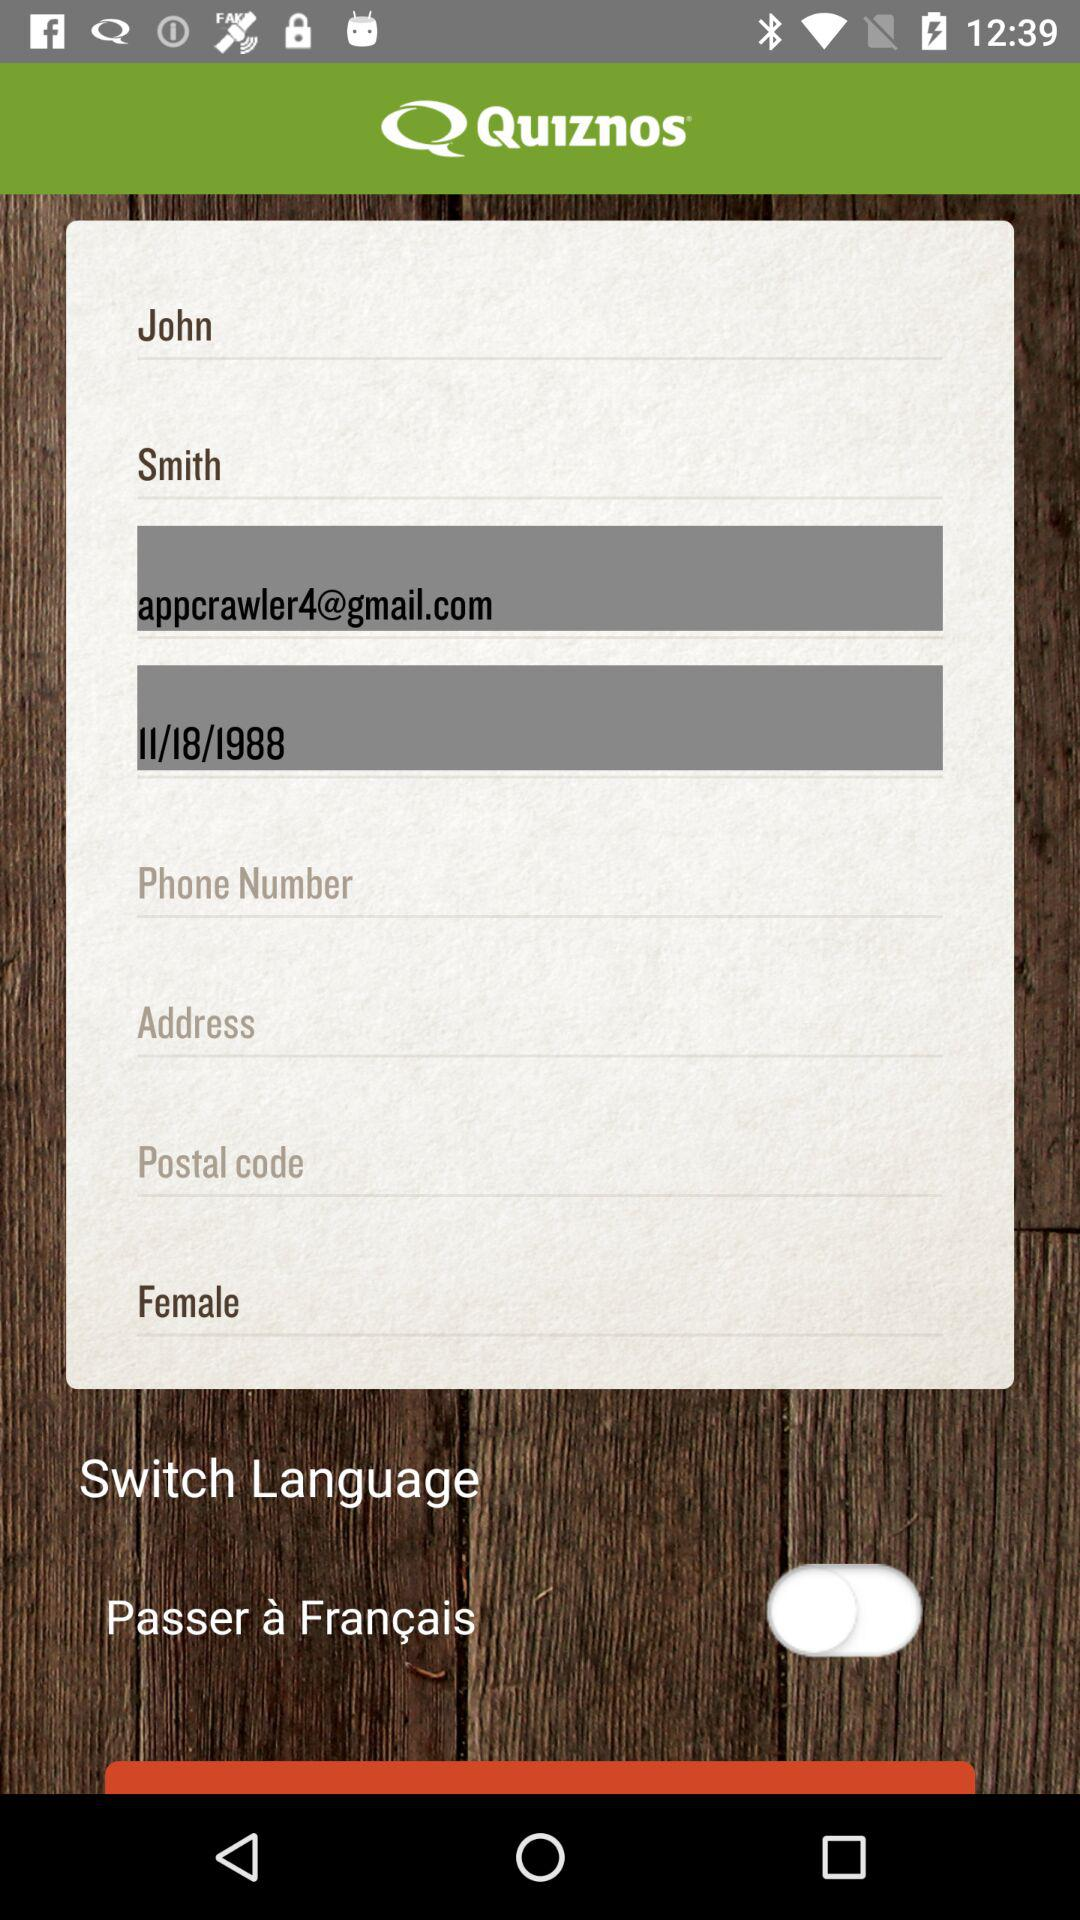What gender is given? The given gender is female. 